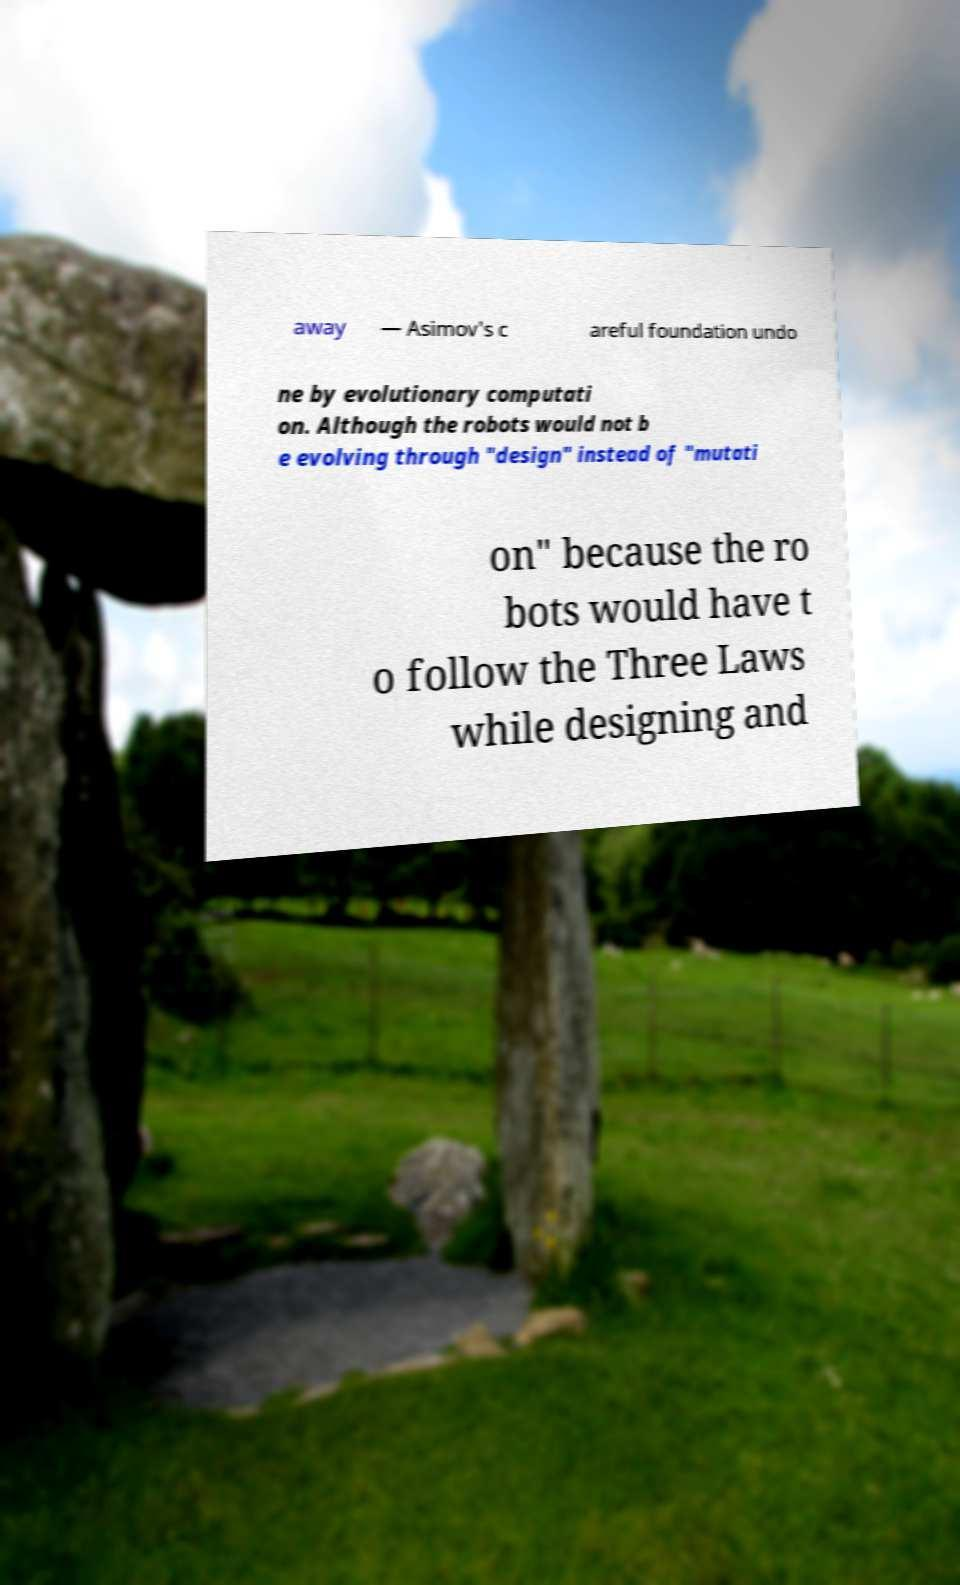There's text embedded in this image that I need extracted. Can you transcribe it verbatim? away — Asimov's c areful foundation undo ne by evolutionary computati on. Although the robots would not b e evolving through "design" instead of "mutati on" because the ro bots would have t o follow the Three Laws while designing and 